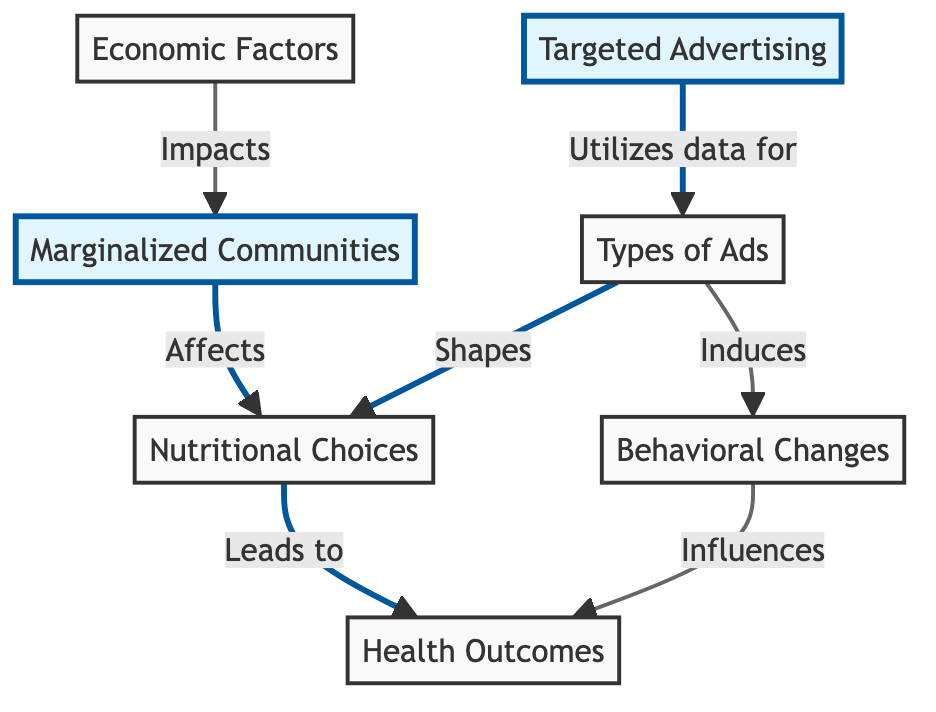What is the main influencing factor identified in the diagram? The main influencing factor identified in the diagram is "Targeted Advertising." It is positioned at the start of the flowchart, indicating its primary role in influencing subsequent elements.
Answer: Targeted Advertising How many nodes are represented in the diagram? There are six main nodes represented in the diagram: "Targeted Advertising," "Types of Ads," "Dietary Choices," "Health Outcomes," "Behavioral Changes," and "Marginalized Communities." Counting these gives a total of six nodes.
Answer: 6 What are the two nodes that interact with "Diet Choices"? The two nodes that interact with "Diet Choices" are "Types of Ads" and "Marginalized Communities." "Types of Ads" leads to "Diet Choices," and "Marginalized Communities" also affects "Diet Choices."
Answer: Types of Ads, Marginalized Communities Which arrow indicates the influence of targeted advertising on behavioral changes? The arrow that indicates this influence is the one connecting "Types of Ads" to "Behavioral Changes." This shows that the types of advertisements directed at communities can induce changes in behavior.
Answer: Types of Ads to Behavioral Changes What is the final impact of dietary choices in the diagram? The final impact of dietary choices in the diagram is on "Health Outcomes." The flow connects "Diet Choices" directly to "Health Outcomes," suggesting that the choices made ultimately affect health results.
Answer: Health Outcomes How does economic factors relate to marginalized communities in the diagram? Economic factors "Impacts" marginalized communities in the diagram, directly linking the socioeconomic environment to the community's overall conditions, and possibly influencing their responses to advertisements.
Answer: Impacts What is the relationship between "Behavioral Changes" and "Health Outcomes"? "Behavioral Changes" "Influences" "Health Outcomes," meaning that the changes in behavior resulting from targeted advertising can lead to different health results in the community.
Answer: Influences 